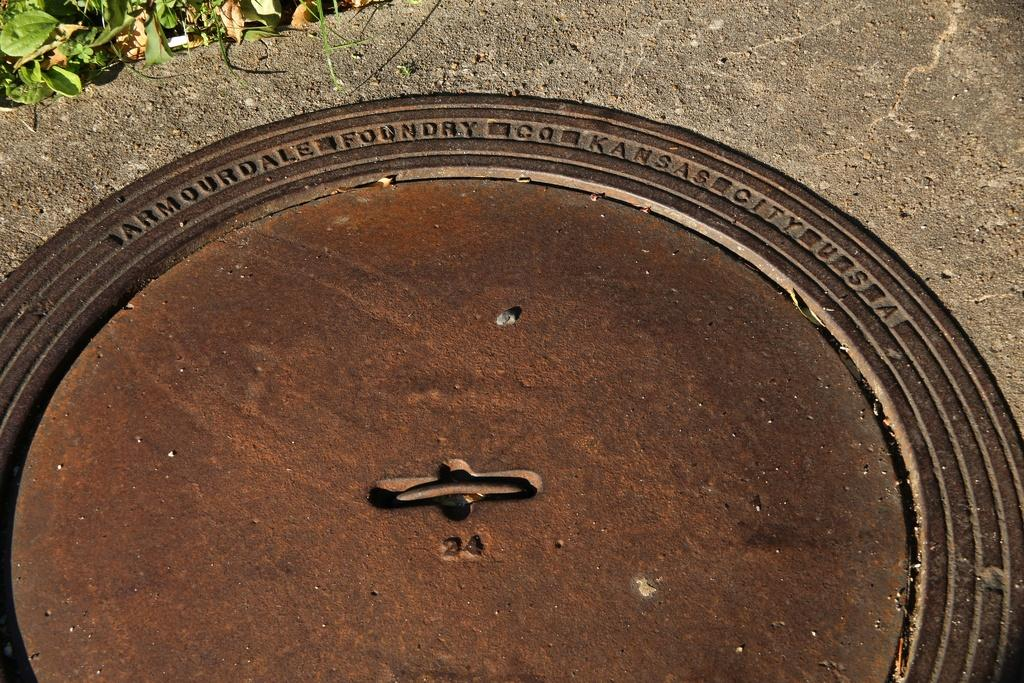What is the main object in the image? There is a slab in the image. What is placed on the slab? There is a round thing with something written on it on the slab. What can be seen at the top of the image? Leaves are visible at the top of the image. What type of copper material is used to make the round thing on the slab? There is no mention of copper or any specific material used to make the round thing on the slab in the image. --- Facts: 1. There is a person sitting on a chair in the image. 2. The person is holding a book. 3. There is a table next to the chair. 4. There is a lamp on the table. Absurd Topics: parrot, ocean, bicycle Conversation: What is the person in the image doing? The person is sitting on a chair in the image. What is the person holding? The person is holding a book. What is located next to the chair? There is a table next to the chair. What is on the table? There is a lamp on the table. Reasoning: Let's think step by step in order to produce the conversation. We start by identifying the main subject in the image, which is the person sitting on a chair. Then, we describe what the person is holding, which is a book. Next, we mention the table that is located next to the chair. Finally, we describe the object on the table, which is a lamp. Each question is designed to elicit a specific detail about the image that is known from the provided facts. Absurd Question/Answer: Can you see a parrot flying over the ocean in the image? There is no parrot or ocean present in the image; it features a person sitting on a chair holding a book, with a table and lamp nearby. 